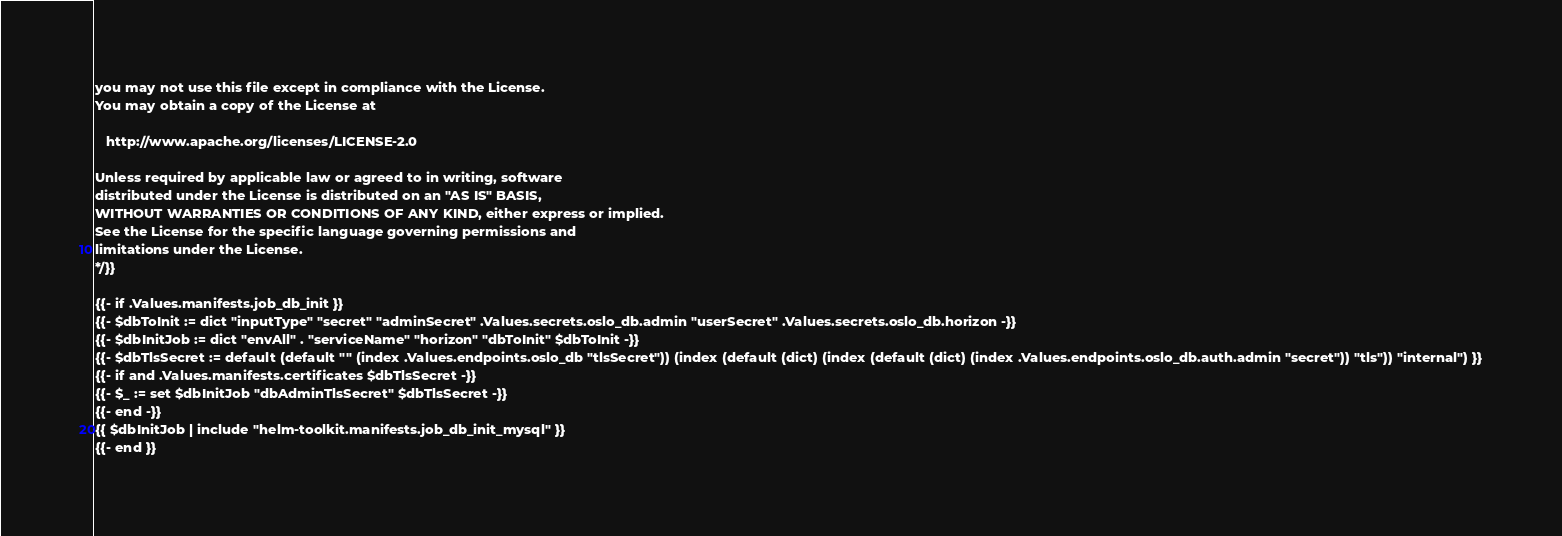Convert code to text. <code><loc_0><loc_0><loc_500><loc_500><_YAML_>you may not use this file except in compliance with the License.
You may obtain a copy of the License at

   http://www.apache.org/licenses/LICENSE-2.0

Unless required by applicable law or agreed to in writing, software
distributed under the License is distributed on an "AS IS" BASIS,
WITHOUT WARRANTIES OR CONDITIONS OF ANY KIND, either express or implied.
See the License for the specific language governing permissions and
limitations under the License.
*/}}

{{- if .Values.manifests.job_db_init }}
{{- $dbToInit := dict "inputType" "secret" "adminSecret" .Values.secrets.oslo_db.admin "userSecret" .Values.secrets.oslo_db.horizon -}}
{{- $dbInitJob := dict "envAll" . "serviceName" "horizon" "dbToInit" $dbToInit -}}
{{- $dbTlsSecret := default (default "" (index .Values.endpoints.oslo_db "tlsSecret")) (index (default (dict) (index (default (dict) (index .Values.endpoints.oslo_db.auth.admin "secret")) "tls")) "internal") }}
{{- if and .Values.manifests.certificates $dbTlsSecret -}}
{{- $_ := set $dbInitJob "dbAdminTlsSecret" $dbTlsSecret -}}
{{- end -}}
{{ $dbInitJob | include "helm-toolkit.manifests.job_db_init_mysql" }}
{{- end }}
</code> 